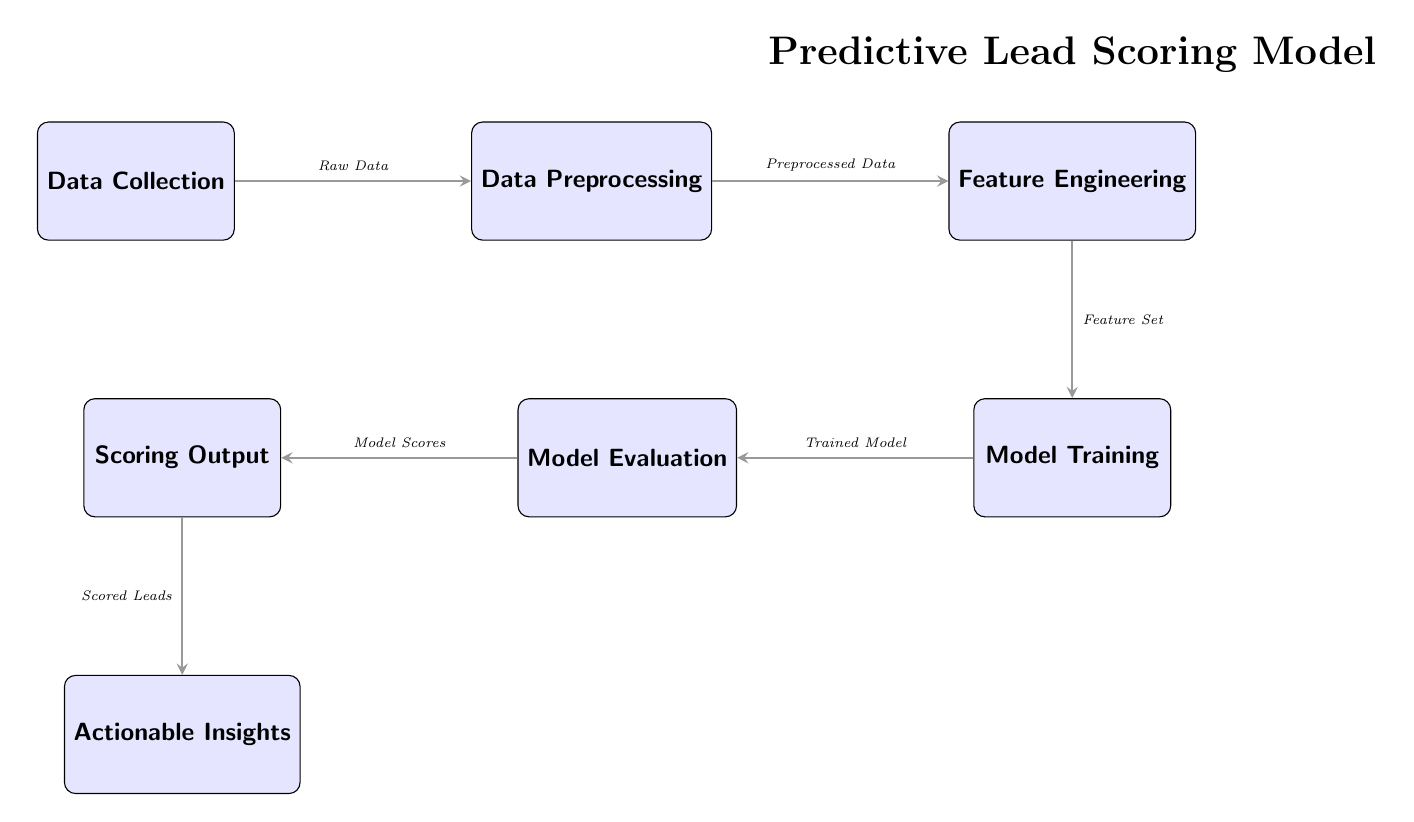What's the first step in the predictive lead scoring model? The first step in the diagram is "Data Collection", which is positioned at the far left and indicates the initial phase in the modeling process.
Answer: Data Collection How many nodes are in the predictive lead scoring model? By counting the rectangles in the diagram, there are a total of six nodes representing different stages of the model.
Answer: Six What does the edge from "Data Collection" to "Data Preprocessing" represent? The edge indicates the flow of information, specifically that "Raw Data" is passed from "Data Collection" to "Data Preprocessing" where it will be prepared for analysis.
Answer: Raw Data What is the output of the model evaluation step? The output of the "Model Evaluation" step is "Model Scores", which shows the effectiveness of the trained model before generating a scoring output.
Answer: Model Scores What is the relationship between "Feature Engineering" and "Model Training"? "Feature Engineering" is the step that leads directly into "Model Training" as it provides the "Feature Set" necessary for building the model.
Answer: Feature Set What insights can be derived from the "Scoring Output"? The "Scoring Output" leads to "Actionable Insights", indicating that the scored leads can be translated into specific, actionable strategies for the marketing team.
Answer: Actionable Insights Which step directly follows "Model Training"? After "Model Training," the next step in the flow is "Model Evaluation," where the effectiveness of the trained model is assessed.
Answer: Model Evaluation What type of data is used in the "Data Preprocessing" step? The "Data Preprocessing" step utilizes "Preprocessed Data," which is the result of cleaning and transforming the raw data collected in the first step.
Answer: Preprocessed Data How does the model utilize the features from the feature engineering phase? The features developed in "Feature Engineering" are crucial for "Model Training," allowing the model to learn patterns that will predict lead conversion rates.
Answer: Model Training 